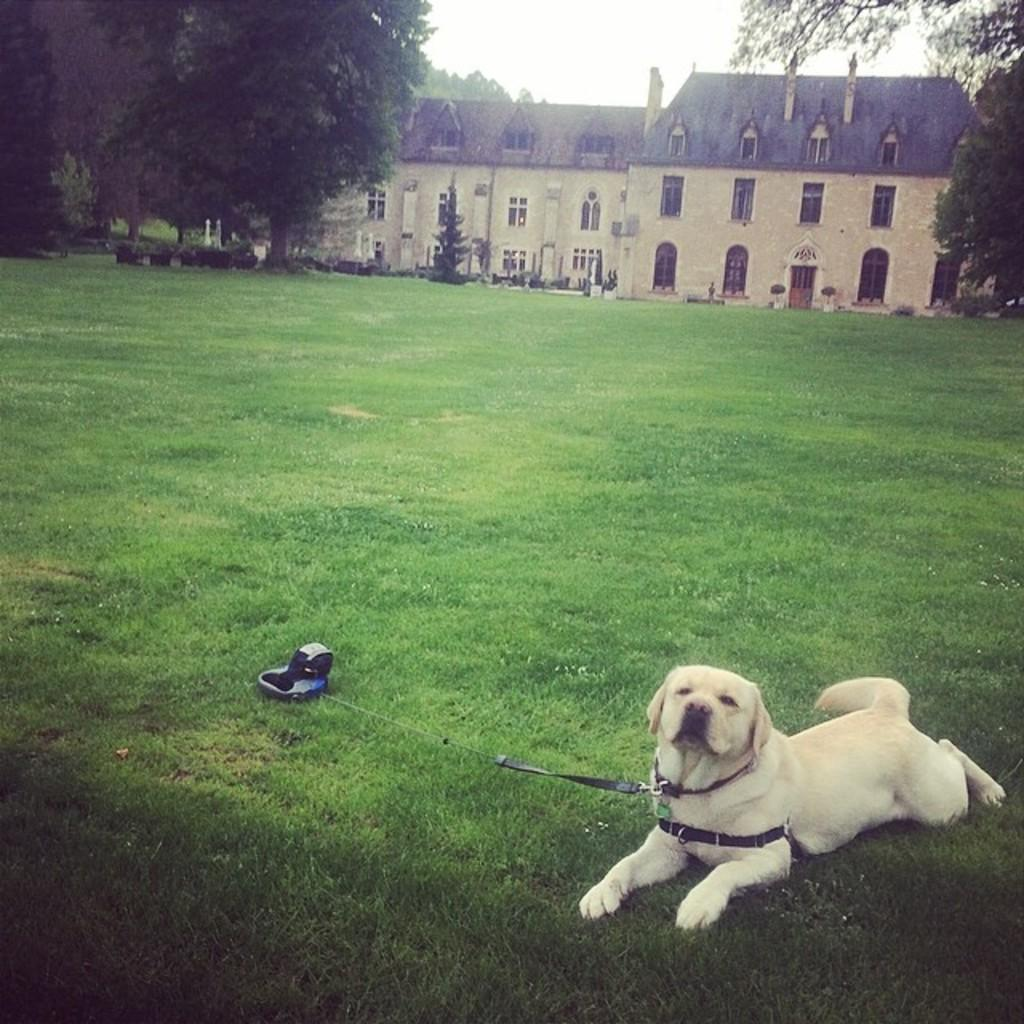What animal can be seen in the image? There is a dog in the image. Where is the dog located? The dog is sitting on the grass. What can be seen in the background of the image? There is a building, trees, plants, and the sky visible in the background of the image. How much money is the dog holding in the image? There is no money present in the image; the dog is sitting on the grass. 